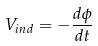Convert formula to latex. <formula><loc_0><loc_0><loc_500><loc_500>V _ { i n d } = - \frac { d \phi } { d t }</formula> 